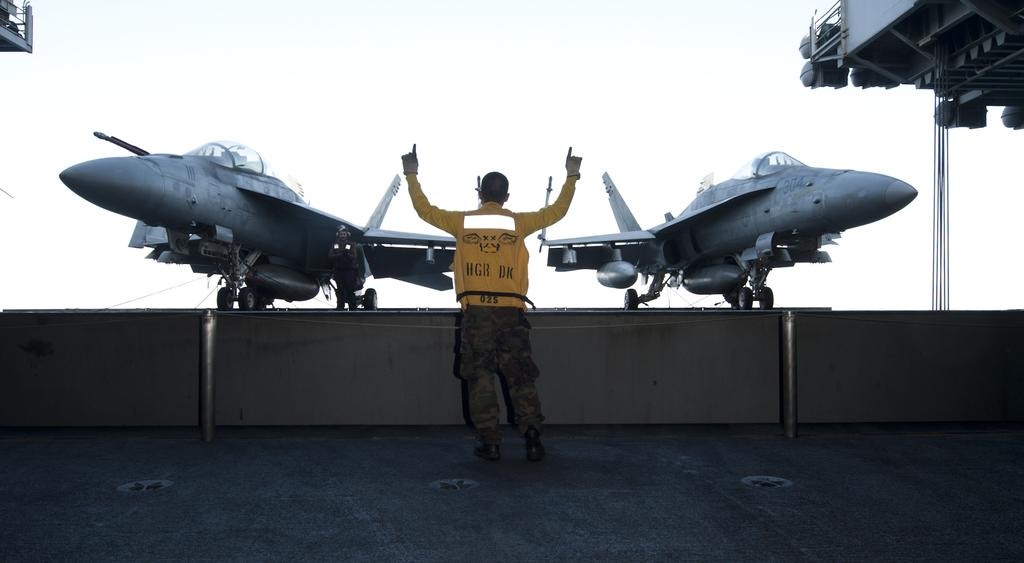How many airplanes are in the image? There are two airplanes in the image. What else can be seen in the image besides the airplanes? There is a man standing in the middle of the image. What is the man standing near in the image? The man is standing near a roof in the image. Can you see the man's friend in the image? There is no friend visible in the image; only the man is present. What type of needle is being used by the man in the image? There is no needle present in the image; the man is simply standing. 